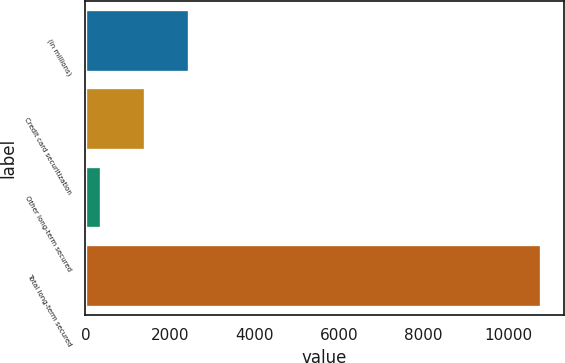<chart> <loc_0><loc_0><loc_500><loc_500><bar_chart><fcel>(in millions)<fcel>Credit card securitization<fcel>Other long-term secured<fcel>Total long-term secured<nl><fcel>2456.2<fcel>1416.6<fcel>377<fcel>10773<nl></chart> 